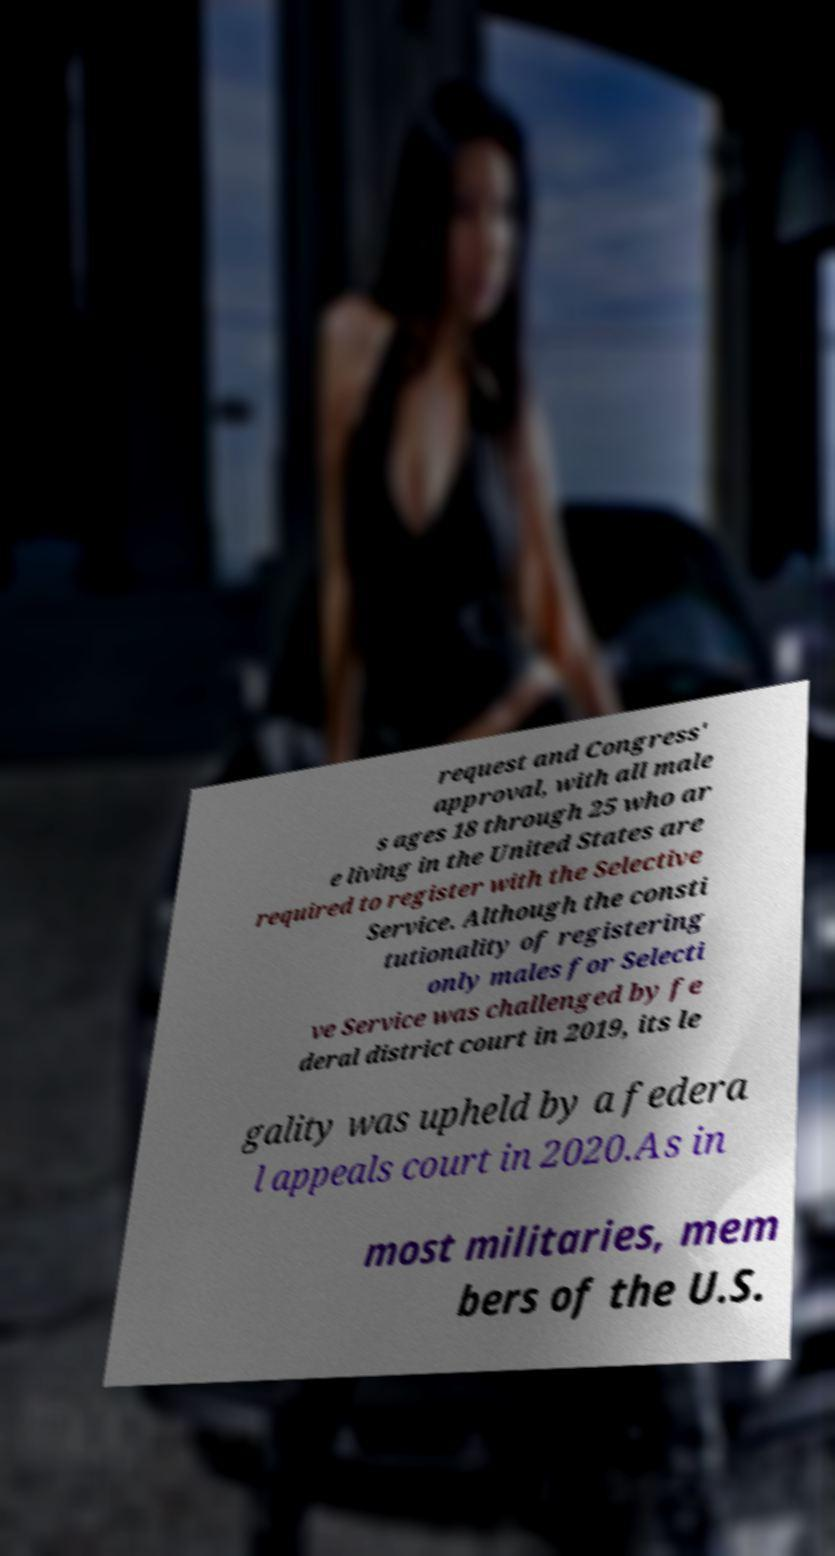For documentation purposes, I need the text within this image transcribed. Could you provide that? request and Congress' approval, with all male s ages 18 through 25 who ar e living in the United States are required to register with the Selective Service. Although the consti tutionality of registering only males for Selecti ve Service was challenged by fe deral district court in 2019, its le gality was upheld by a federa l appeals court in 2020.As in most militaries, mem bers of the U.S. 